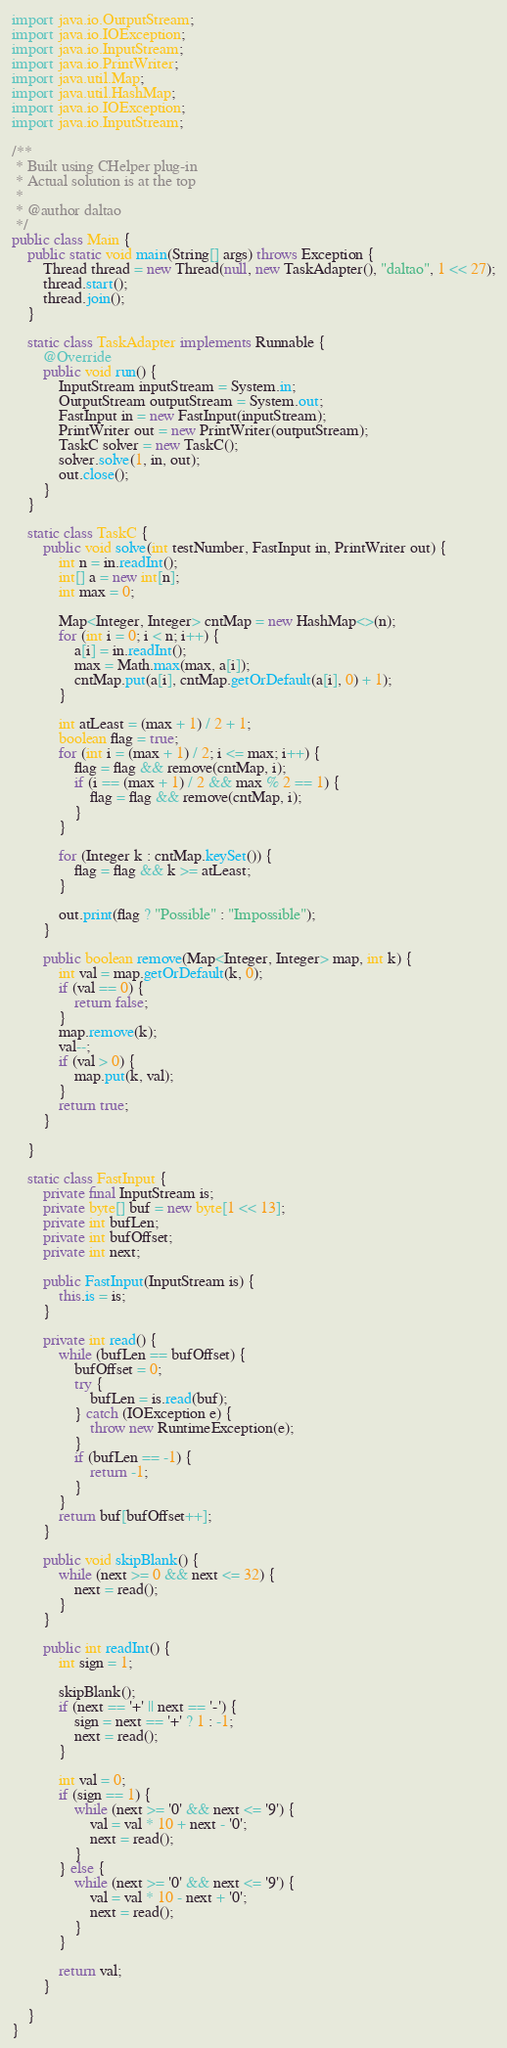<code> <loc_0><loc_0><loc_500><loc_500><_Java_>import java.io.OutputStream;
import java.io.IOException;
import java.io.InputStream;
import java.io.PrintWriter;
import java.util.Map;
import java.util.HashMap;
import java.io.IOException;
import java.io.InputStream;

/**
 * Built using CHelper plug-in
 * Actual solution is at the top
 *
 * @author daltao
 */
public class Main {
    public static void main(String[] args) throws Exception {
        Thread thread = new Thread(null, new TaskAdapter(), "daltao", 1 << 27);
        thread.start();
        thread.join();
    }

    static class TaskAdapter implements Runnable {
        @Override
        public void run() {
            InputStream inputStream = System.in;
            OutputStream outputStream = System.out;
            FastInput in = new FastInput(inputStream);
            PrintWriter out = new PrintWriter(outputStream);
            TaskC solver = new TaskC();
            solver.solve(1, in, out);
            out.close();
        }
    }

    static class TaskC {
        public void solve(int testNumber, FastInput in, PrintWriter out) {
            int n = in.readInt();
            int[] a = new int[n];
            int max = 0;

            Map<Integer, Integer> cntMap = new HashMap<>(n);
            for (int i = 0; i < n; i++) {
                a[i] = in.readInt();
                max = Math.max(max, a[i]);
                cntMap.put(a[i], cntMap.getOrDefault(a[i], 0) + 1);
            }

            int atLeast = (max + 1) / 2 + 1;
            boolean flag = true;
            for (int i = (max + 1) / 2; i <= max; i++) {
                flag = flag && remove(cntMap, i);
                if (i == (max + 1) / 2 && max % 2 == 1) {
                    flag = flag && remove(cntMap, i);
                }
            }

            for (Integer k : cntMap.keySet()) {
                flag = flag && k >= atLeast;
            }

            out.print(flag ? "Possible" : "Impossible");
        }

        public boolean remove(Map<Integer, Integer> map, int k) {
            int val = map.getOrDefault(k, 0);
            if (val == 0) {
                return false;
            }
            map.remove(k);
            val--;
            if (val > 0) {
                map.put(k, val);
            }
            return true;
        }

    }

    static class FastInput {
        private final InputStream is;
        private byte[] buf = new byte[1 << 13];
        private int bufLen;
        private int bufOffset;
        private int next;

        public FastInput(InputStream is) {
            this.is = is;
        }

        private int read() {
            while (bufLen == bufOffset) {
                bufOffset = 0;
                try {
                    bufLen = is.read(buf);
                } catch (IOException e) {
                    throw new RuntimeException(e);
                }
                if (bufLen == -1) {
                    return -1;
                }
            }
            return buf[bufOffset++];
        }

        public void skipBlank() {
            while (next >= 0 && next <= 32) {
                next = read();
            }
        }

        public int readInt() {
            int sign = 1;

            skipBlank();
            if (next == '+' || next == '-') {
                sign = next == '+' ? 1 : -1;
                next = read();
            }

            int val = 0;
            if (sign == 1) {
                while (next >= '0' && next <= '9') {
                    val = val * 10 + next - '0';
                    next = read();
                }
            } else {
                while (next >= '0' && next <= '9') {
                    val = val * 10 - next + '0';
                    next = read();
                }
            }

            return val;
        }

    }
}

</code> 